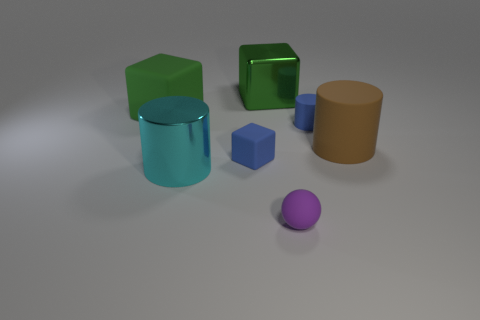Add 1 green matte objects. How many objects exist? 8 Subtract all cubes. How many objects are left? 4 Subtract all big green things. Subtract all green blocks. How many objects are left? 3 Add 7 small blue cylinders. How many small blue cylinders are left? 8 Add 2 gray cubes. How many gray cubes exist? 2 Subtract 1 brown cylinders. How many objects are left? 6 